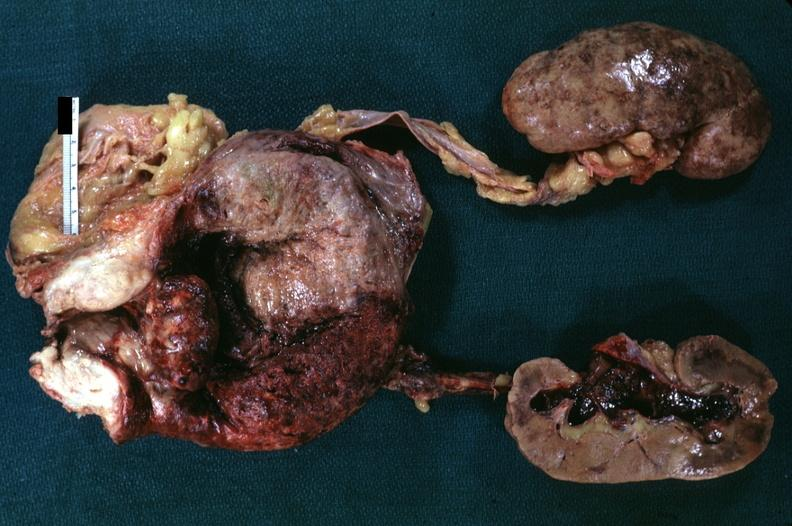s hyperplasia present?
Answer the question using a single word or phrase. Yes 